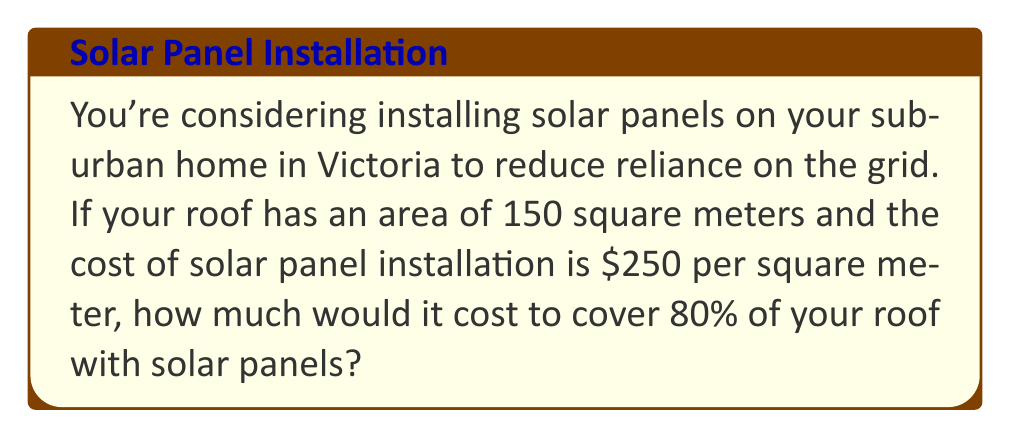Could you help me with this problem? Let's break this down step-by-step:

1. First, we need to calculate 80% of the total roof area:
   $$ 80\% \text{ of } 150 \text{ m}^2 = 0.8 \times 150 \text{ m}^2 = 120 \text{ m}^2 $$

2. Now that we know the area to be covered, we can calculate the total cost:
   $$ \text{Cost} = \text{Area} \times \text{Cost per square meter} $$
   $$ \text{Cost} = 120 \text{ m}^2 \times \$250/\text{m}^2 = \$30,000 $$

Therefore, to cover 80% of your 150 square meter roof with solar panels at a rate of $250 per square meter, it would cost $30,000.
Answer: $30,000 